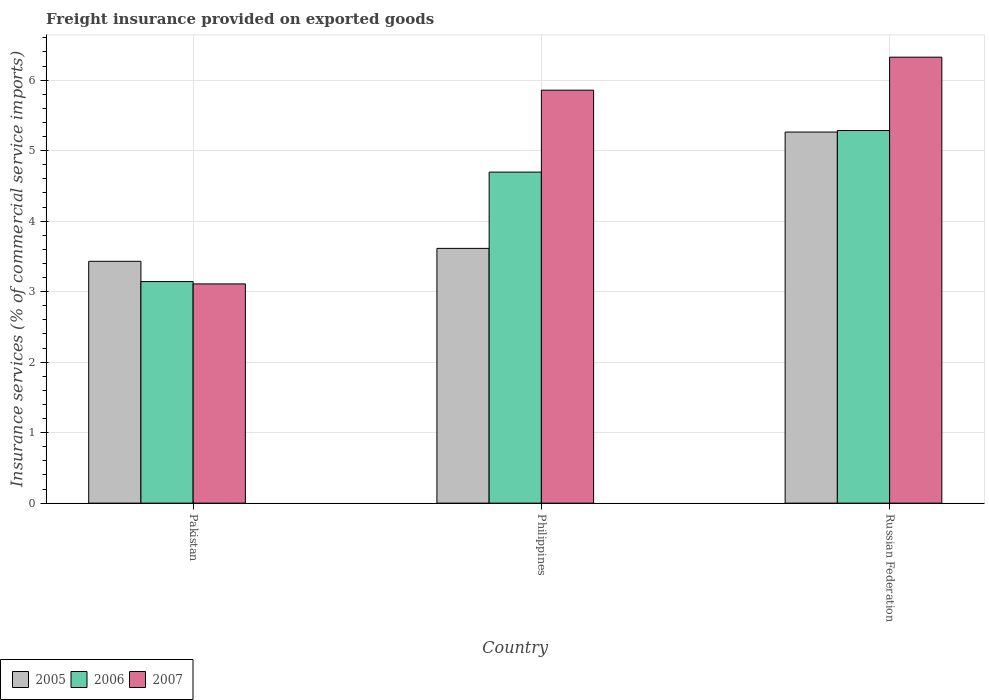How many different coloured bars are there?
Offer a very short reply. 3. How many groups of bars are there?
Keep it short and to the point. 3. Are the number of bars per tick equal to the number of legend labels?
Give a very brief answer. Yes. Are the number of bars on each tick of the X-axis equal?
Make the answer very short. Yes. What is the label of the 2nd group of bars from the left?
Provide a succinct answer. Philippines. In how many cases, is the number of bars for a given country not equal to the number of legend labels?
Your answer should be very brief. 0. What is the freight insurance provided on exported goods in 2006 in Pakistan?
Provide a short and direct response. 3.14. Across all countries, what is the maximum freight insurance provided on exported goods in 2007?
Your answer should be compact. 6.33. Across all countries, what is the minimum freight insurance provided on exported goods in 2006?
Make the answer very short. 3.14. In which country was the freight insurance provided on exported goods in 2007 maximum?
Keep it short and to the point. Russian Federation. What is the total freight insurance provided on exported goods in 2007 in the graph?
Your answer should be compact. 15.29. What is the difference between the freight insurance provided on exported goods in 2007 in Philippines and that in Russian Federation?
Provide a short and direct response. -0.47. What is the difference between the freight insurance provided on exported goods in 2006 in Pakistan and the freight insurance provided on exported goods in 2005 in Philippines?
Offer a very short reply. -0.47. What is the average freight insurance provided on exported goods in 2007 per country?
Ensure brevity in your answer.  5.1. What is the difference between the freight insurance provided on exported goods of/in 2005 and freight insurance provided on exported goods of/in 2006 in Pakistan?
Ensure brevity in your answer.  0.29. In how many countries, is the freight insurance provided on exported goods in 2005 greater than 1 %?
Your response must be concise. 3. What is the ratio of the freight insurance provided on exported goods in 2005 in Pakistan to that in Philippines?
Make the answer very short. 0.95. Is the freight insurance provided on exported goods in 2007 in Philippines less than that in Russian Federation?
Provide a short and direct response. Yes. Is the difference between the freight insurance provided on exported goods in 2005 in Pakistan and Philippines greater than the difference between the freight insurance provided on exported goods in 2006 in Pakistan and Philippines?
Offer a very short reply. Yes. What is the difference between the highest and the second highest freight insurance provided on exported goods in 2006?
Your response must be concise. -1.55. What is the difference between the highest and the lowest freight insurance provided on exported goods in 2007?
Offer a very short reply. 3.22. In how many countries, is the freight insurance provided on exported goods in 2006 greater than the average freight insurance provided on exported goods in 2006 taken over all countries?
Your answer should be very brief. 2. Is the sum of the freight insurance provided on exported goods in 2006 in Pakistan and Philippines greater than the maximum freight insurance provided on exported goods in 2007 across all countries?
Make the answer very short. Yes. What does the 1st bar from the right in Russian Federation represents?
Give a very brief answer. 2007. How many bars are there?
Offer a very short reply. 9. Are the values on the major ticks of Y-axis written in scientific E-notation?
Your response must be concise. No. Does the graph contain grids?
Offer a terse response. Yes. Where does the legend appear in the graph?
Give a very brief answer. Bottom left. How many legend labels are there?
Make the answer very short. 3. What is the title of the graph?
Your answer should be very brief. Freight insurance provided on exported goods. What is the label or title of the X-axis?
Your answer should be very brief. Country. What is the label or title of the Y-axis?
Your answer should be very brief. Insurance services (% of commercial service imports). What is the Insurance services (% of commercial service imports) in 2005 in Pakistan?
Your answer should be very brief. 3.43. What is the Insurance services (% of commercial service imports) of 2006 in Pakistan?
Keep it short and to the point. 3.14. What is the Insurance services (% of commercial service imports) in 2007 in Pakistan?
Make the answer very short. 3.11. What is the Insurance services (% of commercial service imports) in 2005 in Philippines?
Make the answer very short. 3.61. What is the Insurance services (% of commercial service imports) of 2006 in Philippines?
Ensure brevity in your answer.  4.7. What is the Insurance services (% of commercial service imports) of 2007 in Philippines?
Make the answer very short. 5.86. What is the Insurance services (% of commercial service imports) in 2005 in Russian Federation?
Provide a short and direct response. 5.26. What is the Insurance services (% of commercial service imports) of 2006 in Russian Federation?
Keep it short and to the point. 5.29. What is the Insurance services (% of commercial service imports) of 2007 in Russian Federation?
Offer a very short reply. 6.33. Across all countries, what is the maximum Insurance services (% of commercial service imports) in 2005?
Offer a terse response. 5.26. Across all countries, what is the maximum Insurance services (% of commercial service imports) of 2006?
Make the answer very short. 5.29. Across all countries, what is the maximum Insurance services (% of commercial service imports) in 2007?
Keep it short and to the point. 6.33. Across all countries, what is the minimum Insurance services (% of commercial service imports) in 2005?
Make the answer very short. 3.43. Across all countries, what is the minimum Insurance services (% of commercial service imports) in 2006?
Ensure brevity in your answer.  3.14. Across all countries, what is the minimum Insurance services (% of commercial service imports) of 2007?
Your answer should be compact. 3.11. What is the total Insurance services (% of commercial service imports) of 2005 in the graph?
Keep it short and to the point. 12.31. What is the total Insurance services (% of commercial service imports) of 2006 in the graph?
Offer a very short reply. 13.12. What is the total Insurance services (% of commercial service imports) in 2007 in the graph?
Keep it short and to the point. 15.29. What is the difference between the Insurance services (% of commercial service imports) in 2005 in Pakistan and that in Philippines?
Offer a very short reply. -0.18. What is the difference between the Insurance services (% of commercial service imports) of 2006 in Pakistan and that in Philippines?
Keep it short and to the point. -1.55. What is the difference between the Insurance services (% of commercial service imports) in 2007 in Pakistan and that in Philippines?
Offer a very short reply. -2.75. What is the difference between the Insurance services (% of commercial service imports) of 2005 in Pakistan and that in Russian Federation?
Your answer should be compact. -1.83. What is the difference between the Insurance services (% of commercial service imports) in 2006 in Pakistan and that in Russian Federation?
Offer a terse response. -2.14. What is the difference between the Insurance services (% of commercial service imports) in 2007 in Pakistan and that in Russian Federation?
Give a very brief answer. -3.22. What is the difference between the Insurance services (% of commercial service imports) of 2005 in Philippines and that in Russian Federation?
Ensure brevity in your answer.  -1.65. What is the difference between the Insurance services (% of commercial service imports) in 2006 in Philippines and that in Russian Federation?
Ensure brevity in your answer.  -0.59. What is the difference between the Insurance services (% of commercial service imports) of 2007 in Philippines and that in Russian Federation?
Make the answer very short. -0.47. What is the difference between the Insurance services (% of commercial service imports) of 2005 in Pakistan and the Insurance services (% of commercial service imports) of 2006 in Philippines?
Give a very brief answer. -1.27. What is the difference between the Insurance services (% of commercial service imports) of 2005 in Pakistan and the Insurance services (% of commercial service imports) of 2007 in Philippines?
Provide a short and direct response. -2.43. What is the difference between the Insurance services (% of commercial service imports) of 2006 in Pakistan and the Insurance services (% of commercial service imports) of 2007 in Philippines?
Give a very brief answer. -2.71. What is the difference between the Insurance services (% of commercial service imports) in 2005 in Pakistan and the Insurance services (% of commercial service imports) in 2006 in Russian Federation?
Offer a terse response. -1.85. What is the difference between the Insurance services (% of commercial service imports) of 2005 in Pakistan and the Insurance services (% of commercial service imports) of 2007 in Russian Federation?
Make the answer very short. -2.9. What is the difference between the Insurance services (% of commercial service imports) of 2006 in Pakistan and the Insurance services (% of commercial service imports) of 2007 in Russian Federation?
Make the answer very short. -3.18. What is the difference between the Insurance services (% of commercial service imports) of 2005 in Philippines and the Insurance services (% of commercial service imports) of 2006 in Russian Federation?
Your answer should be compact. -1.67. What is the difference between the Insurance services (% of commercial service imports) in 2005 in Philippines and the Insurance services (% of commercial service imports) in 2007 in Russian Federation?
Provide a succinct answer. -2.71. What is the difference between the Insurance services (% of commercial service imports) in 2006 in Philippines and the Insurance services (% of commercial service imports) in 2007 in Russian Federation?
Give a very brief answer. -1.63. What is the average Insurance services (% of commercial service imports) in 2005 per country?
Offer a very short reply. 4.1. What is the average Insurance services (% of commercial service imports) of 2006 per country?
Offer a terse response. 4.37. What is the average Insurance services (% of commercial service imports) of 2007 per country?
Your response must be concise. 5.1. What is the difference between the Insurance services (% of commercial service imports) in 2005 and Insurance services (% of commercial service imports) in 2006 in Pakistan?
Make the answer very short. 0.29. What is the difference between the Insurance services (% of commercial service imports) of 2005 and Insurance services (% of commercial service imports) of 2007 in Pakistan?
Offer a very short reply. 0.32. What is the difference between the Insurance services (% of commercial service imports) in 2006 and Insurance services (% of commercial service imports) in 2007 in Pakistan?
Ensure brevity in your answer.  0.03. What is the difference between the Insurance services (% of commercial service imports) in 2005 and Insurance services (% of commercial service imports) in 2006 in Philippines?
Keep it short and to the point. -1.08. What is the difference between the Insurance services (% of commercial service imports) of 2005 and Insurance services (% of commercial service imports) of 2007 in Philippines?
Ensure brevity in your answer.  -2.24. What is the difference between the Insurance services (% of commercial service imports) of 2006 and Insurance services (% of commercial service imports) of 2007 in Philippines?
Your response must be concise. -1.16. What is the difference between the Insurance services (% of commercial service imports) in 2005 and Insurance services (% of commercial service imports) in 2006 in Russian Federation?
Offer a very short reply. -0.02. What is the difference between the Insurance services (% of commercial service imports) of 2005 and Insurance services (% of commercial service imports) of 2007 in Russian Federation?
Provide a succinct answer. -1.06. What is the difference between the Insurance services (% of commercial service imports) in 2006 and Insurance services (% of commercial service imports) in 2007 in Russian Federation?
Make the answer very short. -1.04. What is the ratio of the Insurance services (% of commercial service imports) in 2005 in Pakistan to that in Philippines?
Your answer should be compact. 0.95. What is the ratio of the Insurance services (% of commercial service imports) in 2006 in Pakistan to that in Philippines?
Keep it short and to the point. 0.67. What is the ratio of the Insurance services (% of commercial service imports) in 2007 in Pakistan to that in Philippines?
Your answer should be compact. 0.53. What is the ratio of the Insurance services (% of commercial service imports) of 2005 in Pakistan to that in Russian Federation?
Your response must be concise. 0.65. What is the ratio of the Insurance services (% of commercial service imports) of 2006 in Pakistan to that in Russian Federation?
Offer a terse response. 0.59. What is the ratio of the Insurance services (% of commercial service imports) in 2007 in Pakistan to that in Russian Federation?
Provide a succinct answer. 0.49. What is the ratio of the Insurance services (% of commercial service imports) of 2005 in Philippines to that in Russian Federation?
Provide a short and direct response. 0.69. What is the ratio of the Insurance services (% of commercial service imports) in 2006 in Philippines to that in Russian Federation?
Ensure brevity in your answer.  0.89. What is the ratio of the Insurance services (% of commercial service imports) of 2007 in Philippines to that in Russian Federation?
Offer a terse response. 0.93. What is the difference between the highest and the second highest Insurance services (% of commercial service imports) in 2005?
Your answer should be very brief. 1.65. What is the difference between the highest and the second highest Insurance services (% of commercial service imports) of 2006?
Provide a short and direct response. 0.59. What is the difference between the highest and the second highest Insurance services (% of commercial service imports) in 2007?
Give a very brief answer. 0.47. What is the difference between the highest and the lowest Insurance services (% of commercial service imports) in 2005?
Provide a short and direct response. 1.83. What is the difference between the highest and the lowest Insurance services (% of commercial service imports) in 2006?
Provide a succinct answer. 2.14. What is the difference between the highest and the lowest Insurance services (% of commercial service imports) in 2007?
Offer a terse response. 3.22. 